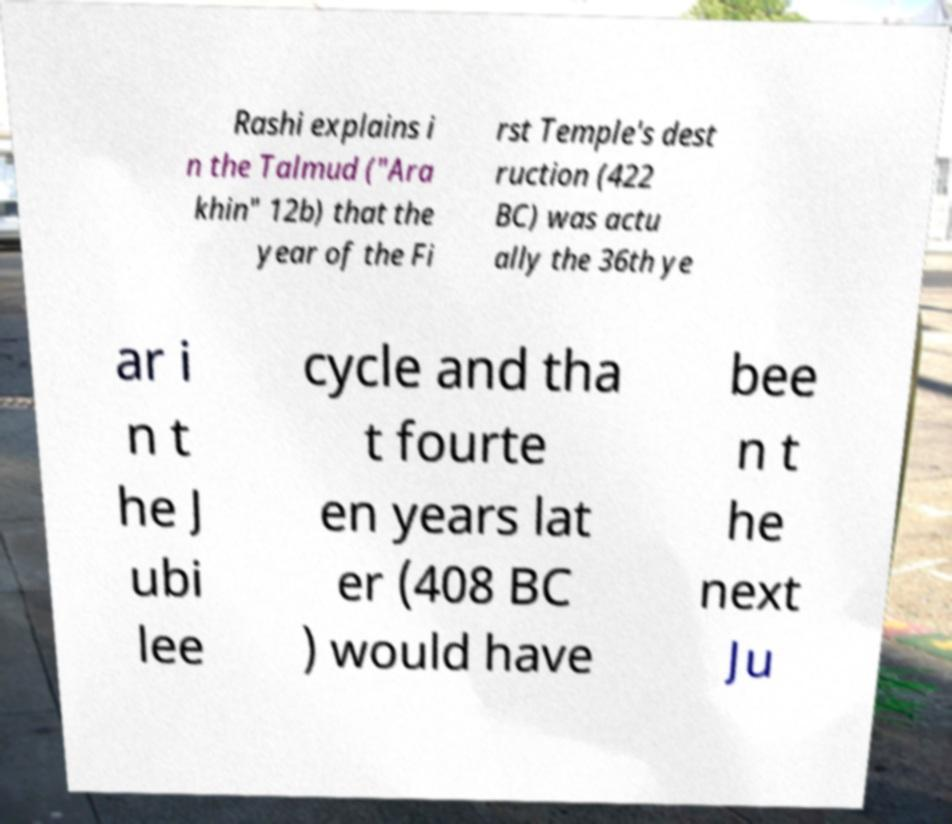For documentation purposes, I need the text within this image transcribed. Could you provide that? Rashi explains i n the Talmud ("Ara khin" 12b) that the year of the Fi rst Temple's dest ruction (422 BC) was actu ally the 36th ye ar i n t he J ubi lee cycle and tha t fourte en years lat er (408 BC ) would have bee n t he next Ju 